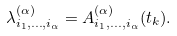<formula> <loc_0><loc_0><loc_500><loc_500>\lambda ^ { ( \alpha ) } _ { i _ { 1 } , \dots , i _ { \alpha } } = A ^ { ( \alpha ) } _ { i _ { 1 } , \dots , i _ { \alpha } } ( t _ { k } ) .</formula> 